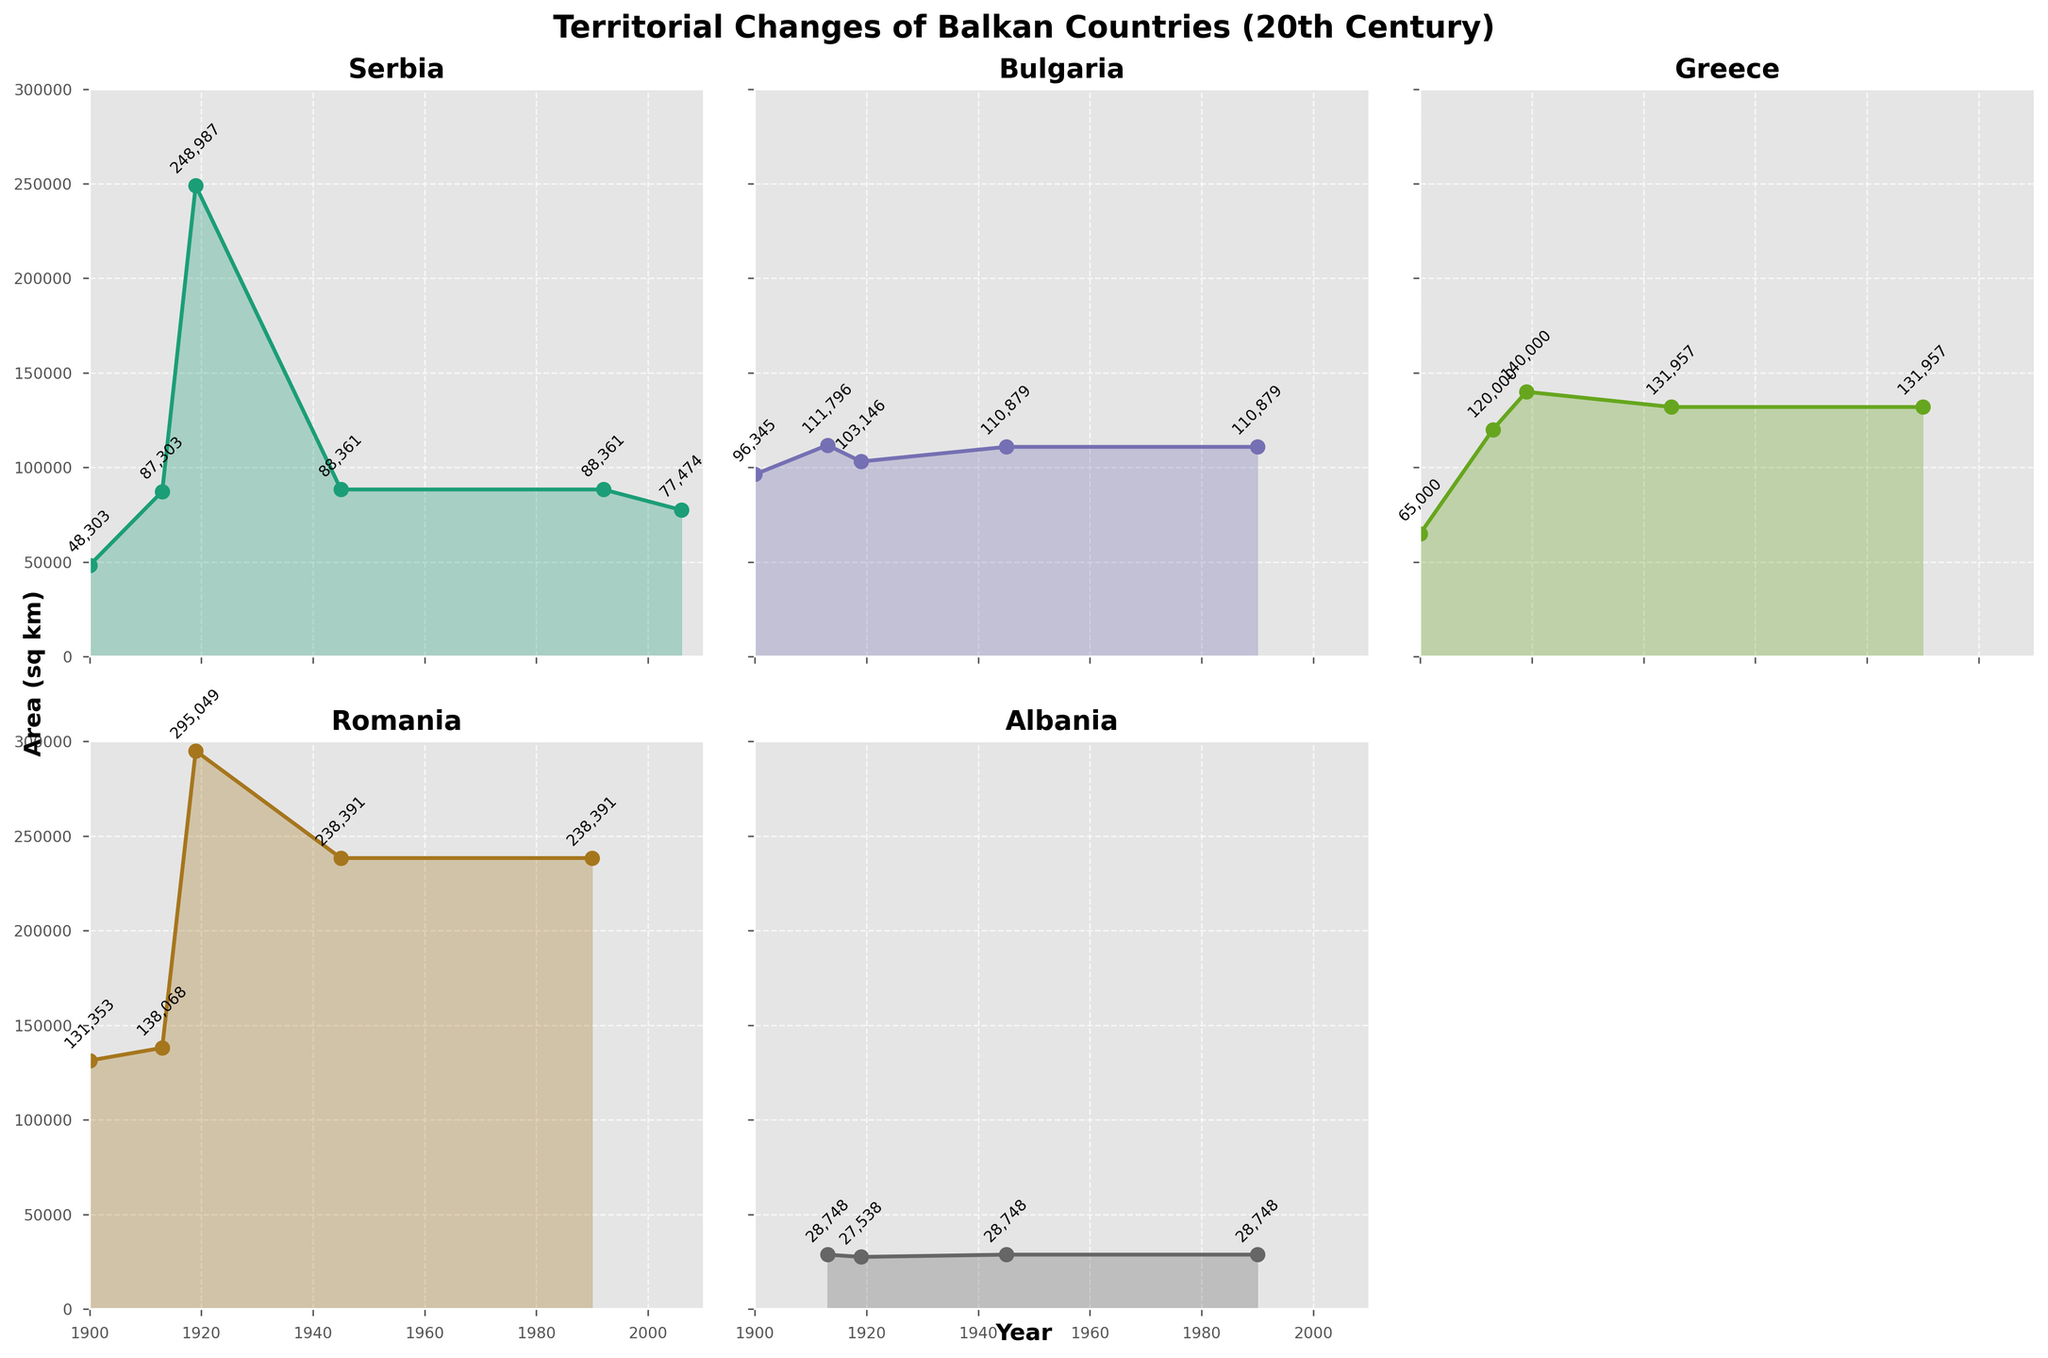Which country had the greatest territorial expansion between 1900 and 1990? Serbia had the greatest territorial expansion. In 1900, Serbia's area was 48,303 sq km which increased to 248,987 sq km by 1919 and remained more than 80,000 sq km until 1990, despite some fluctuations.
Answer: Serbia What is the smallest area that Bulgaria had during the periods shown in the plot? Bulgaria had its smallest area in 1900 with an area of 96,345 sq km. This can be seen in the plot for Bulgaria, where the value increased after 1900.
Answer: 96,345 sq km By how much did Greece's area increase from 1900 to 1919? Greece's area increased from 65,000 sq km in 1900 to 140,000 sq km in 1919. The increase is calculated as 140,000 - 65,000 = 75,000 sq km.
Answer: 75,000 sq km Which country's plot shows a constant area after World War II until 1990? Albania's plot shows a constant area after World War II (1945) all the way to 1990, where the area remains at 28,748 sq km.
Answer: Albania By how much did Romania’s area decrease between 1919 and 1945? Romania's area decreased from 295,049 sq km in 1919 to 238,391 sq km in 1945. The decrease in area is 295,049 - 238,391 = 56,658 sq km.
Answer: 56,658 sq km Which country experienced no changes in territory size after 1945 until 1990? Both Greece and Bulgaria experienced no changes in territory size after 1945 until 1990. Greece maintained an area of 131,957 sq km and Bulgaria remained at 110,879 sq km during this period.
Answer: Greece and Bulgaria What is the area difference between Serbia's largest recorded territory and its size in 2006? Serbia's largest recorded territory was 248,987 sq km in 1919, and its size in 2006 was 77,474 sq km. The difference is 248,987 - 77,474 = 171,513 sq km.
Answer: 171,513 sq km Which country had the smallest area in the year 1913? Albania had the smallest area in 1913 with an area of 28,748 sq km. This can be verified by comparing all plotted areas for different countries in 1913.
Answer: Albania 